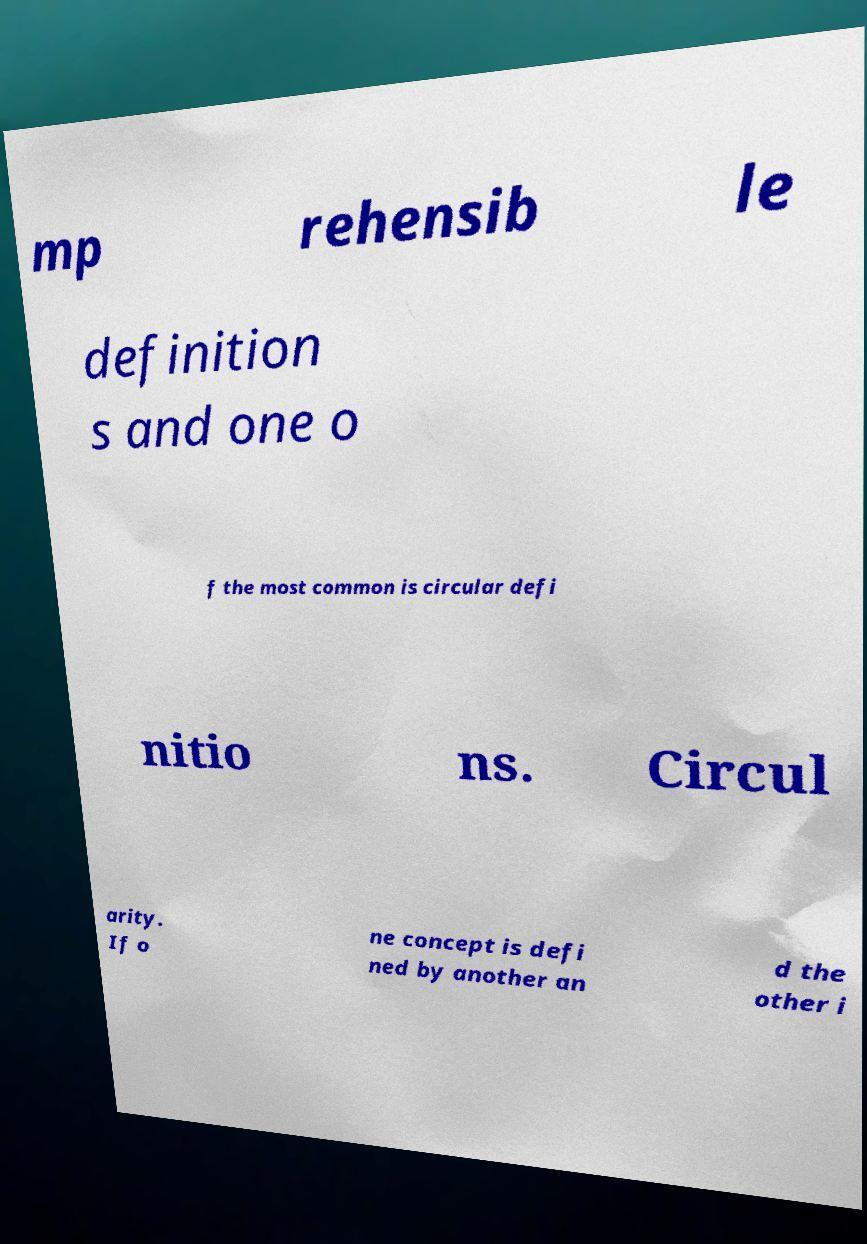There's text embedded in this image that I need extracted. Can you transcribe it verbatim? mp rehensib le definition s and one o f the most common is circular defi nitio ns. Circul arity. If o ne concept is defi ned by another an d the other i 